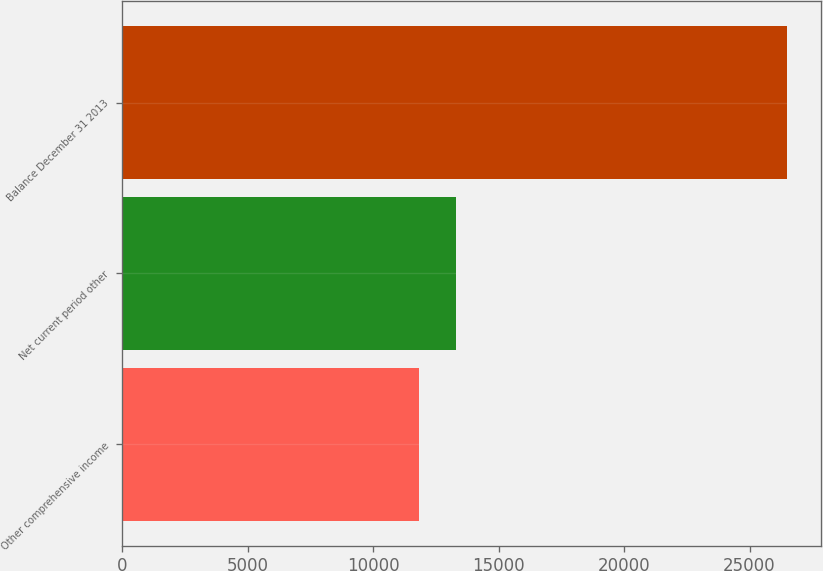Convert chart. <chart><loc_0><loc_0><loc_500><loc_500><bar_chart><fcel>Other comprehensive income<fcel>Net current period other<fcel>Balance December 31 2013<nl><fcel>11838<fcel>13304.8<fcel>26506<nl></chart> 